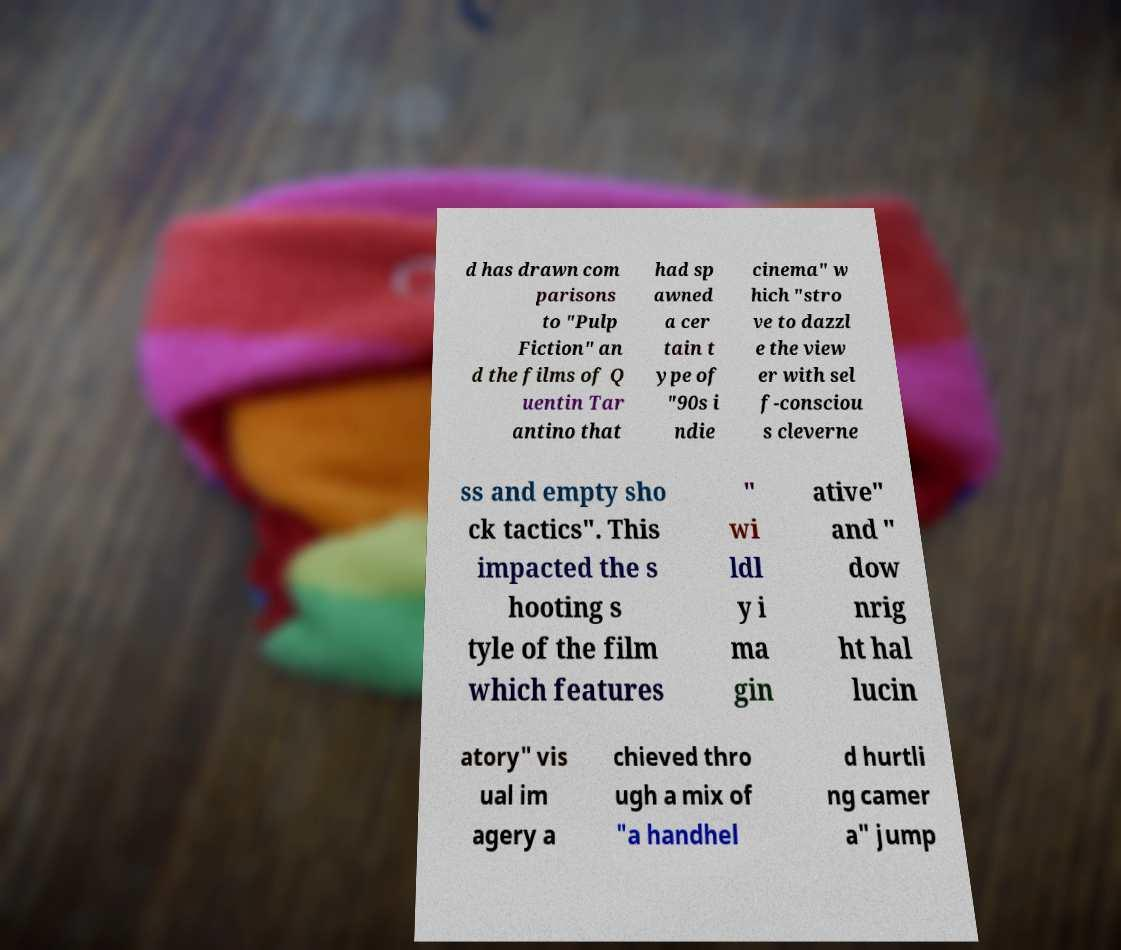There's text embedded in this image that I need extracted. Can you transcribe it verbatim? d has drawn com parisons to "Pulp Fiction" an d the films of Q uentin Tar antino that had sp awned a cer tain t ype of "90s i ndie cinema" w hich "stro ve to dazzl e the view er with sel f-consciou s cleverne ss and empty sho ck tactics". This impacted the s hooting s tyle of the film which features " wi ldl y i ma gin ative" and " dow nrig ht hal lucin atory" vis ual im agery a chieved thro ugh a mix of "a handhel d hurtli ng camer a" jump 